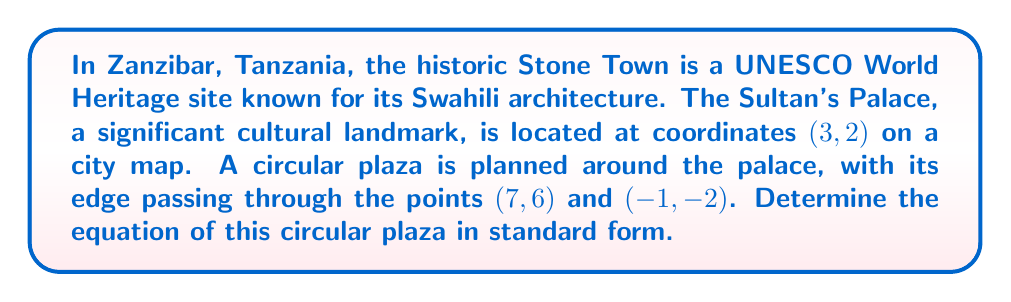Give your solution to this math problem. Let's approach this step-by-step:

1) The general equation of a circle is $$(x-h)^2 + (y-k)^2 = r^2$$
   where $(h,k)$ is the center and $r$ is the radius.

2) We're given that the center is at (3, 2), so $h=3$ and $k=2$.

3) To find $r$, we can use either of the given points on the circle. Let's use (7, 6).

4) The radius is the distance from the center to any point on the circle. We can calculate this using the distance formula:

   $$r = \sqrt{(x_2-x_1)^2 + (y_2-y_1)^2}$$
   $$r = \sqrt{(7-3)^2 + (6-2)^2}$$
   $$r = \sqrt{4^2 + 4^2} = \sqrt{32} = 4\sqrt{2}$$

5) Now we have all the components to write the equation:

   $$(x-3)^2 + (y-2)^2 = (4\sqrt{2})^2$$

6) Simplify the right side:

   $$(x-3)^2 + (y-2)^2 = 32$$

This is the equation of the circle in standard form.

7) To verify, we can check if the other given point (-1, -2) satisfies this equation:

   $$(-1-3)^2 + (-2-2)^2 = (-4)^2 + (-4)^2 = 16 + 16 = 32$$

   It does, confirming our equation is correct.
Answer: $$(x-3)^2 + (y-2)^2 = 32$$ 